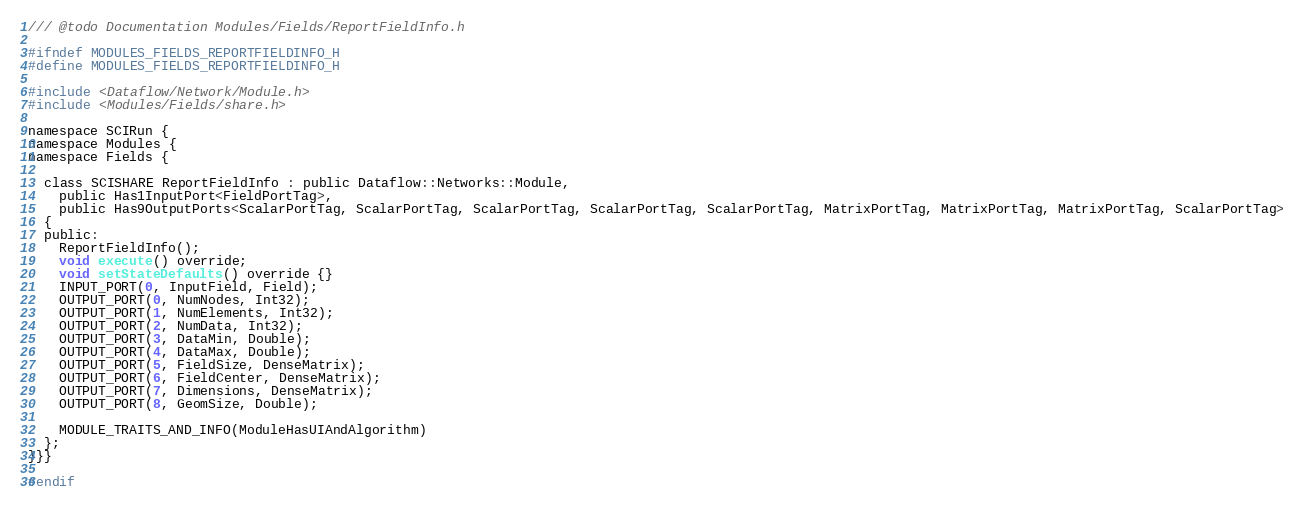<code> <loc_0><loc_0><loc_500><loc_500><_C_>

/// @todo Documentation Modules/Fields/ReportFieldInfo.h

#ifndef MODULES_FIELDS_REPORTFIELDINFO_H
#define MODULES_FIELDS_REPORTFIELDINFO_H

#include <Dataflow/Network/Module.h>
#include <Modules/Fields/share.h>

namespace SCIRun {
namespace Modules {
namespace Fields {

  class SCISHARE ReportFieldInfo : public Dataflow::Networks::Module,
    public Has1InputPort<FieldPortTag>,
    public Has9OutputPorts<ScalarPortTag, ScalarPortTag, ScalarPortTag, ScalarPortTag, ScalarPortTag, MatrixPortTag, MatrixPortTag, MatrixPortTag, ScalarPortTag>
  {
  public:
    ReportFieldInfo();
    void execute() override;
    void setStateDefaults() override {}
    INPUT_PORT(0, InputField, Field);
    OUTPUT_PORT(0, NumNodes, Int32);
    OUTPUT_PORT(1, NumElements, Int32);
    OUTPUT_PORT(2, NumData, Int32);
    OUTPUT_PORT(3, DataMin, Double);
    OUTPUT_PORT(4, DataMax, Double);
    OUTPUT_PORT(5, FieldSize, DenseMatrix);
    OUTPUT_PORT(6, FieldCenter, DenseMatrix);
    OUTPUT_PORT(7, Dimensions, DenseMatrix);
    OUTPUT_PORT(8, GeomSize, Double);

    MODULE_TRAITS_AND_INFO(ModuleHasUIAndAlgorithm)
  };
}}}

#endif
</code> 